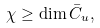Convert formula to latex. <formula><loc_0><loc_0><loc_500><loc_500>\chi \geq \dim \bar { C } _ { u } ,</formula> 